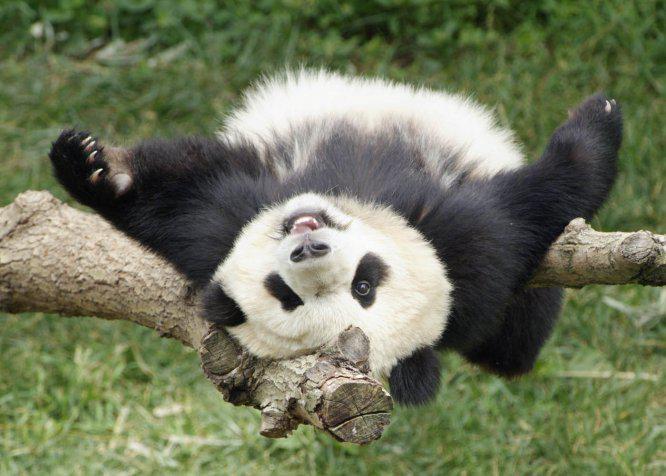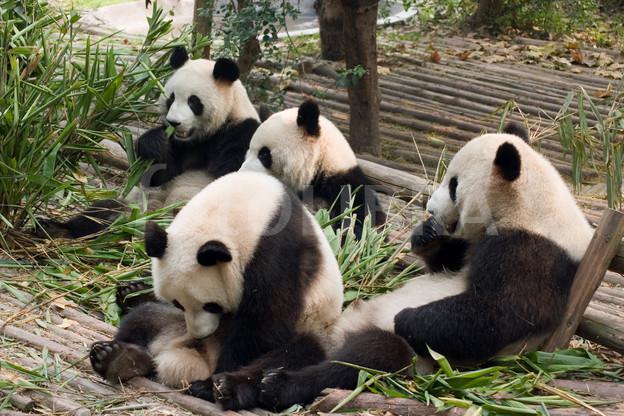The first image is the image on the left, the second image is the image on the right. For the images shown, is this caption "There are at most 5 pandas in the image pair." true? Answer yes or no. Yes. The first image is the image on the left, the second image is the image on the right. Considering the images on both sides, is "One image shows multiple pandas sitting in a group chewing on stalks, and the other includes a panda with its arms flung wide." valid? Answer yes or no. Yes. 